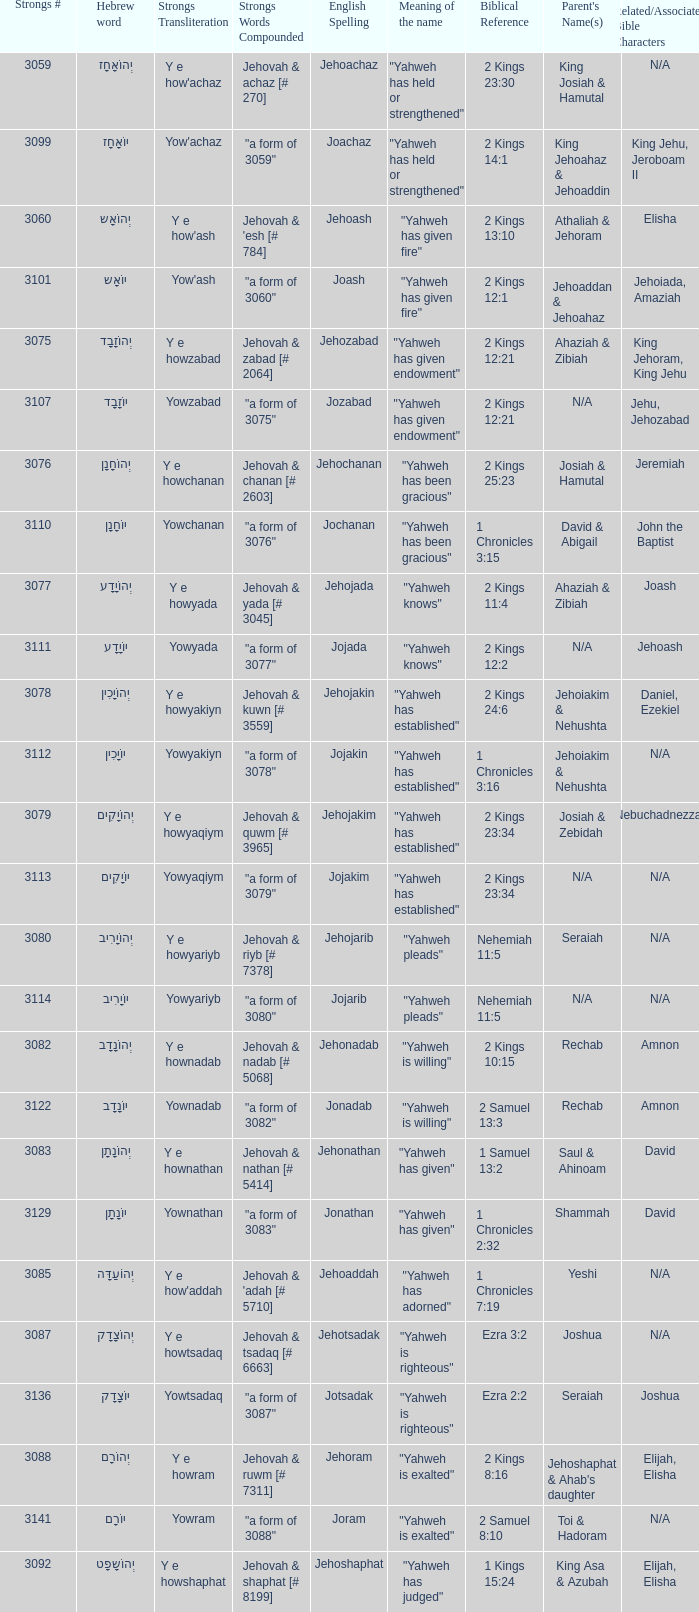What is the strong words compounded when the strongs transliteration is yowyariyb? "a form of 3080". 